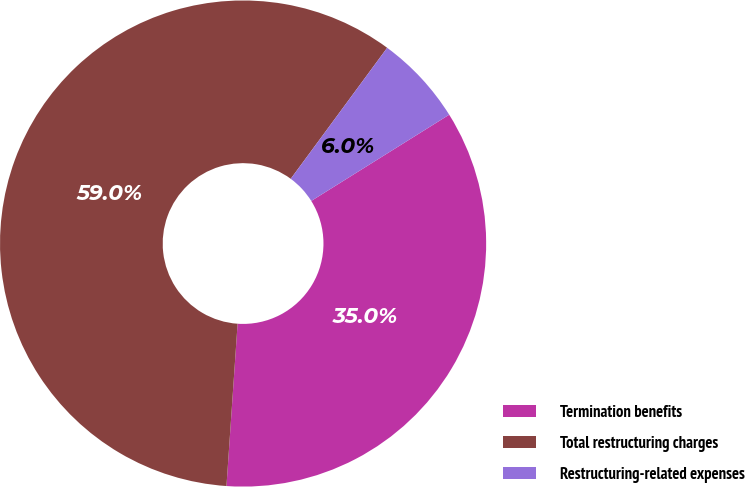Convert chart to OTSL. <chart><loc_0><loc_0><loc_500><loc_500><pie_chart><fcel>Termination benefits<fcel>Total restructuring charges<fcel>Restructuring-related expenses<nl><fcel>34.98%<fcel>59.01%<fcel>6.01%<nl></chart> 